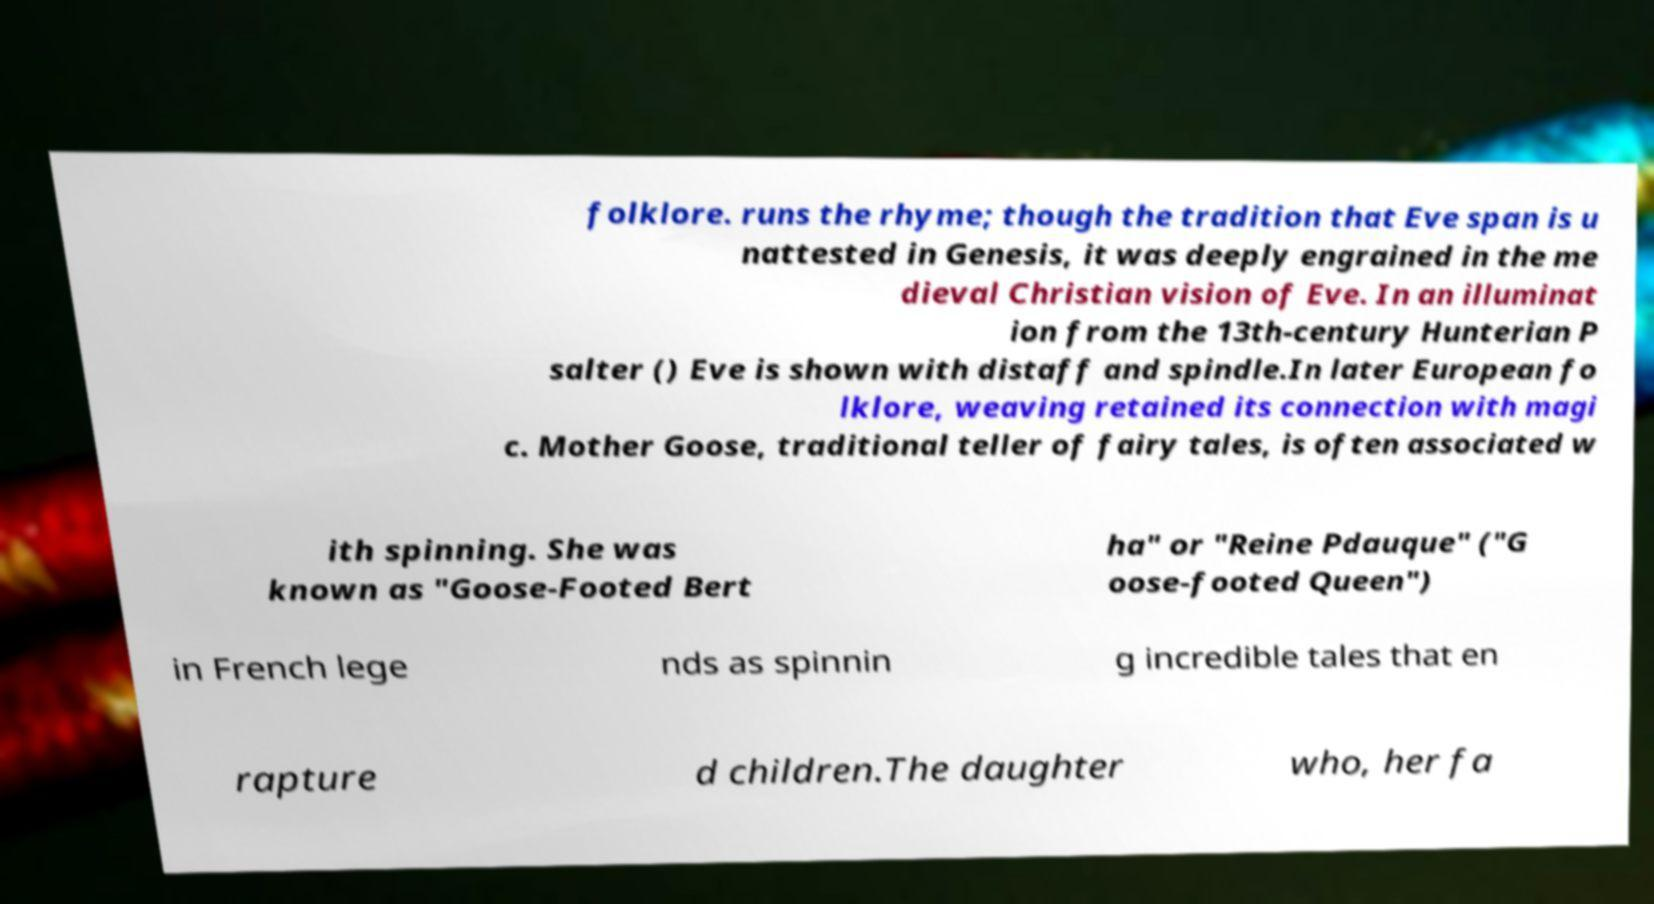Can you accurately transcribe the text from the provided image for me? folklore. runs the rhyme; though the tradition that Eve span is u nattested in Genesis, it was deeply engrained in the me dieval Christian vision of Eve. In an illuminat ion from the 13th-century Hunterian P salter () Eve is shown with distaff and spindle.In later European fo lklore, weaving retained its connection with magi c. Mother Goose, traditional teller of fairy tales, is often associated w ith spinning. She was known as "Goose-Footed Bert ha" or "Reine Pdauque" ("G oose-footed Queen") in French lege nds as spinnin g incredible tales that en rapture d children.The daughter who, her fa 